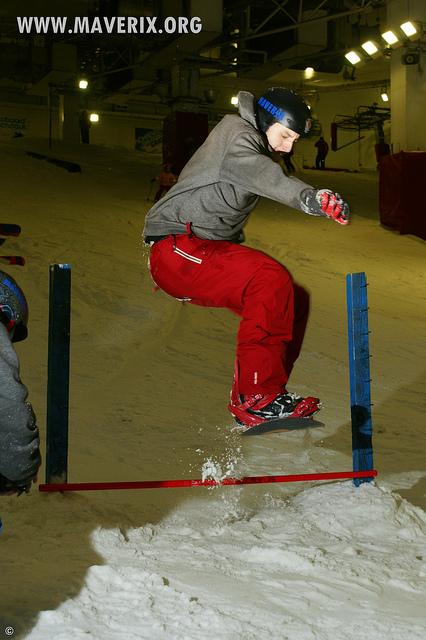What type of activity is taking place?
Answer briefly. Snowboarding. Is this kid in the air?
Concise answer only. Yes. Is the boy snowboarding in the wilderness?
Concise answer only. No. 